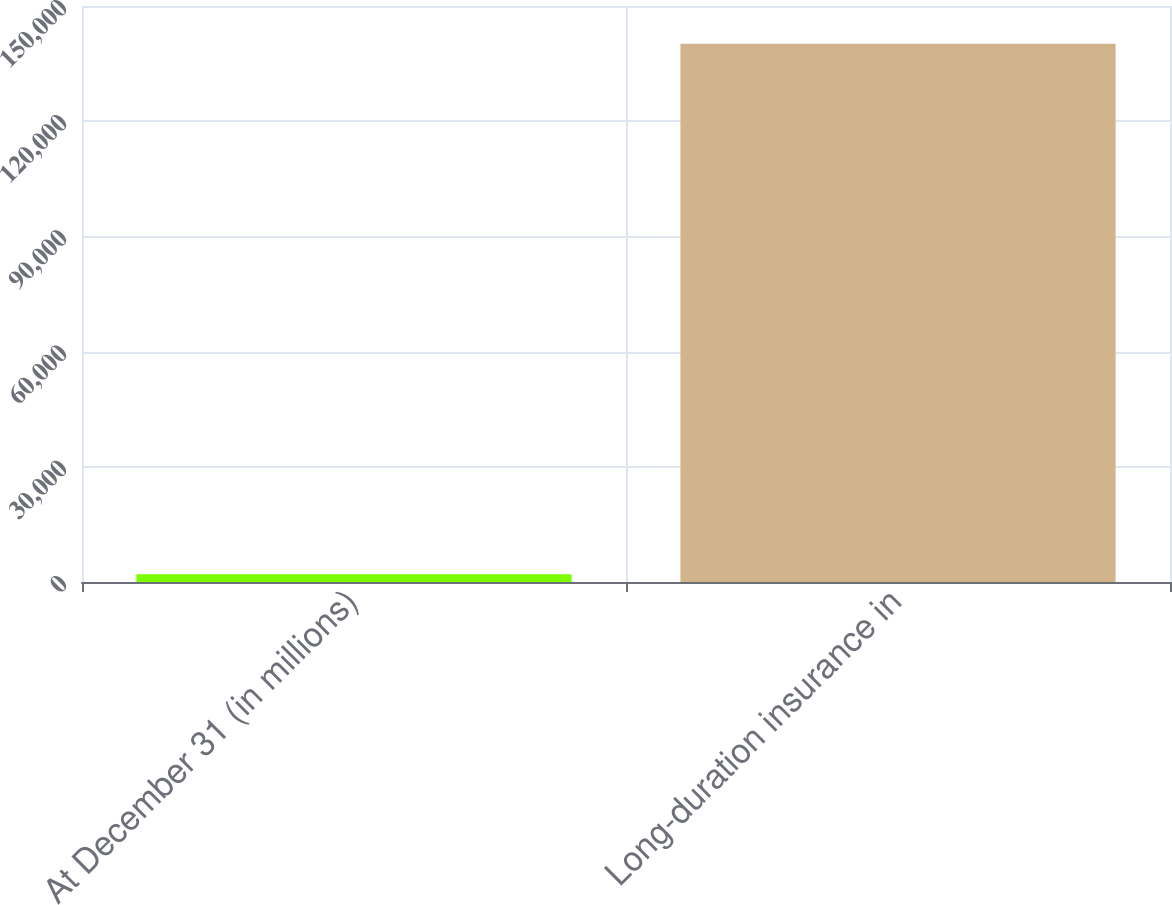Convert chart to OTSL. <chart><loc_0><loc_0><loc_500><loc_500><bar_chart><fcel>At December 31 (in millions)<fcel>Long-duration insurance in<nl><fcel>2011<fcel>140156<nl></chart> 